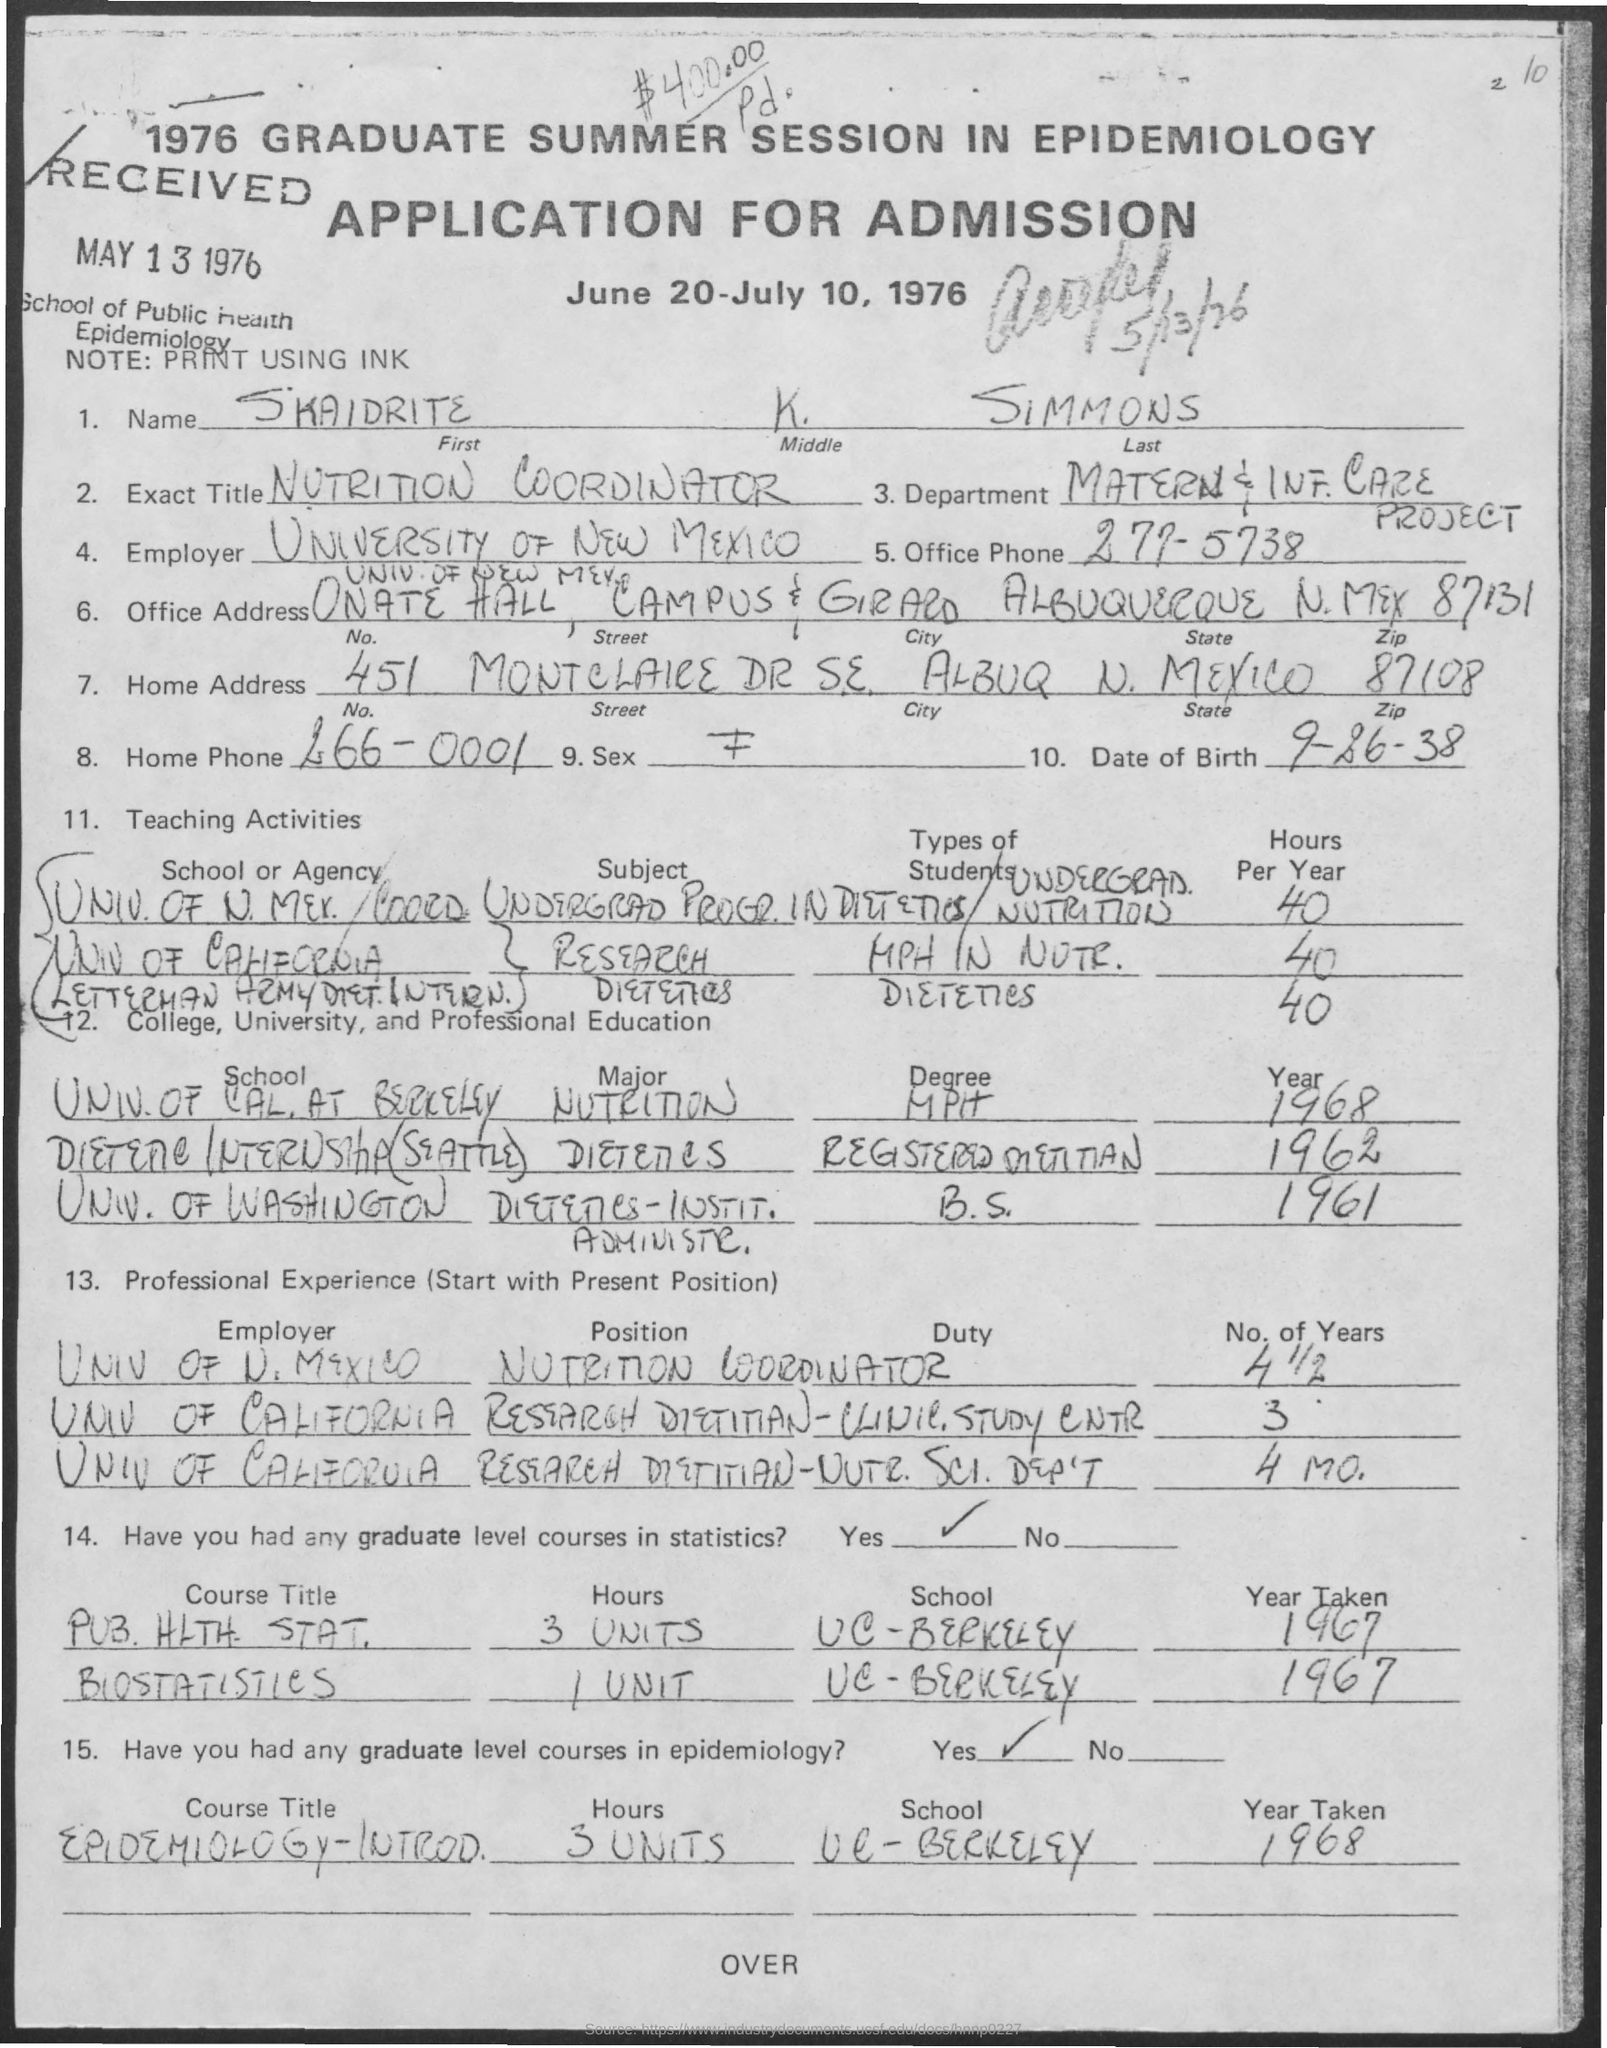What is the full name of the applicant?
Provide a short and direct response. SKAIDRITE K. SIMMONS. What is the Exact Title of the applicant?
Your response must be concise. NUTRITION COORDINATOR. When was the application form RECEIVED?
Your response must be concise. May 13 1976. What is the date of birth of the applicant?
Your answer should be compact. 9-26-38. Which department does this applicant belongs to?
Give a very brief answer. Matern & Inf. Care Project. 